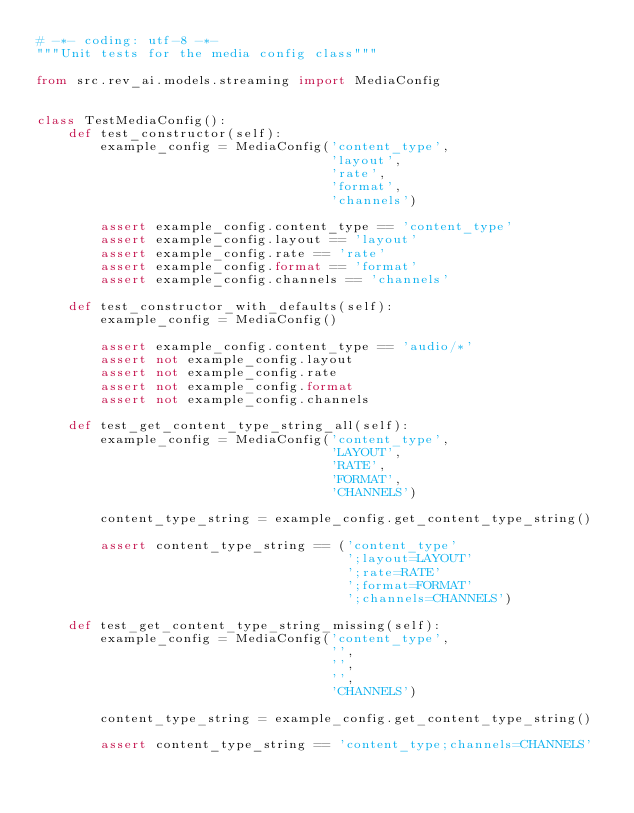<code> <loc_0><loc_0><loc_500><loc_500><_Python_># -*- coding: utf-8 -*-
"""Unit tests for the media config class"""

from src.rev_ai.models.streaming import MediaConfig


class TestMediaConfig():
    def test_constructor(self):
        example_config = MediaConfig('content_type',
                                     'layout',
                                     'rate',
                                     'format',
                                     'channels')

        assert example_config.content_type == 'content_type'
        assert example_config.layout == 'layout'
        assert example_config.rate == 'rate'
        assert example_config.format == 'format'
        assert example_config.channels == 'channels'

    def test_constructor_with_defaults(self):
        example_config = MediaConfig()

        assert example_config.content_type == 'audio/*'
        assert not example_config.layout
        assert not example_config.rate
        assert not example_config.format
        assert not example_config.channels

    def test_get_content_type_string_all(self):
        example_config = MediaConfig('content_type',
                                     'LAYOUT',
                                     'RATE',
                                     'FORMAT',
                                     'CHANNELS')

        content_type_string = example_config.get_content_type_string()

        assert content_type_string == ('content_type'
                                       ';layout=LAYOUT'
                                       ';rate=RATE'
                                       ';format=FORMAT'
                                       ';channels=CHANNELS')

    def test_get_content_type_string_missing(self):
        example_config = MediaConfig('content_type',
                                     '',
                                     '',
                                     '',
                                     'CHANNELS')

        content_type_string = example_config.get_content_type_string()

        assert content_type_string == 'content_type;channels=CHANNELS'
</code> 